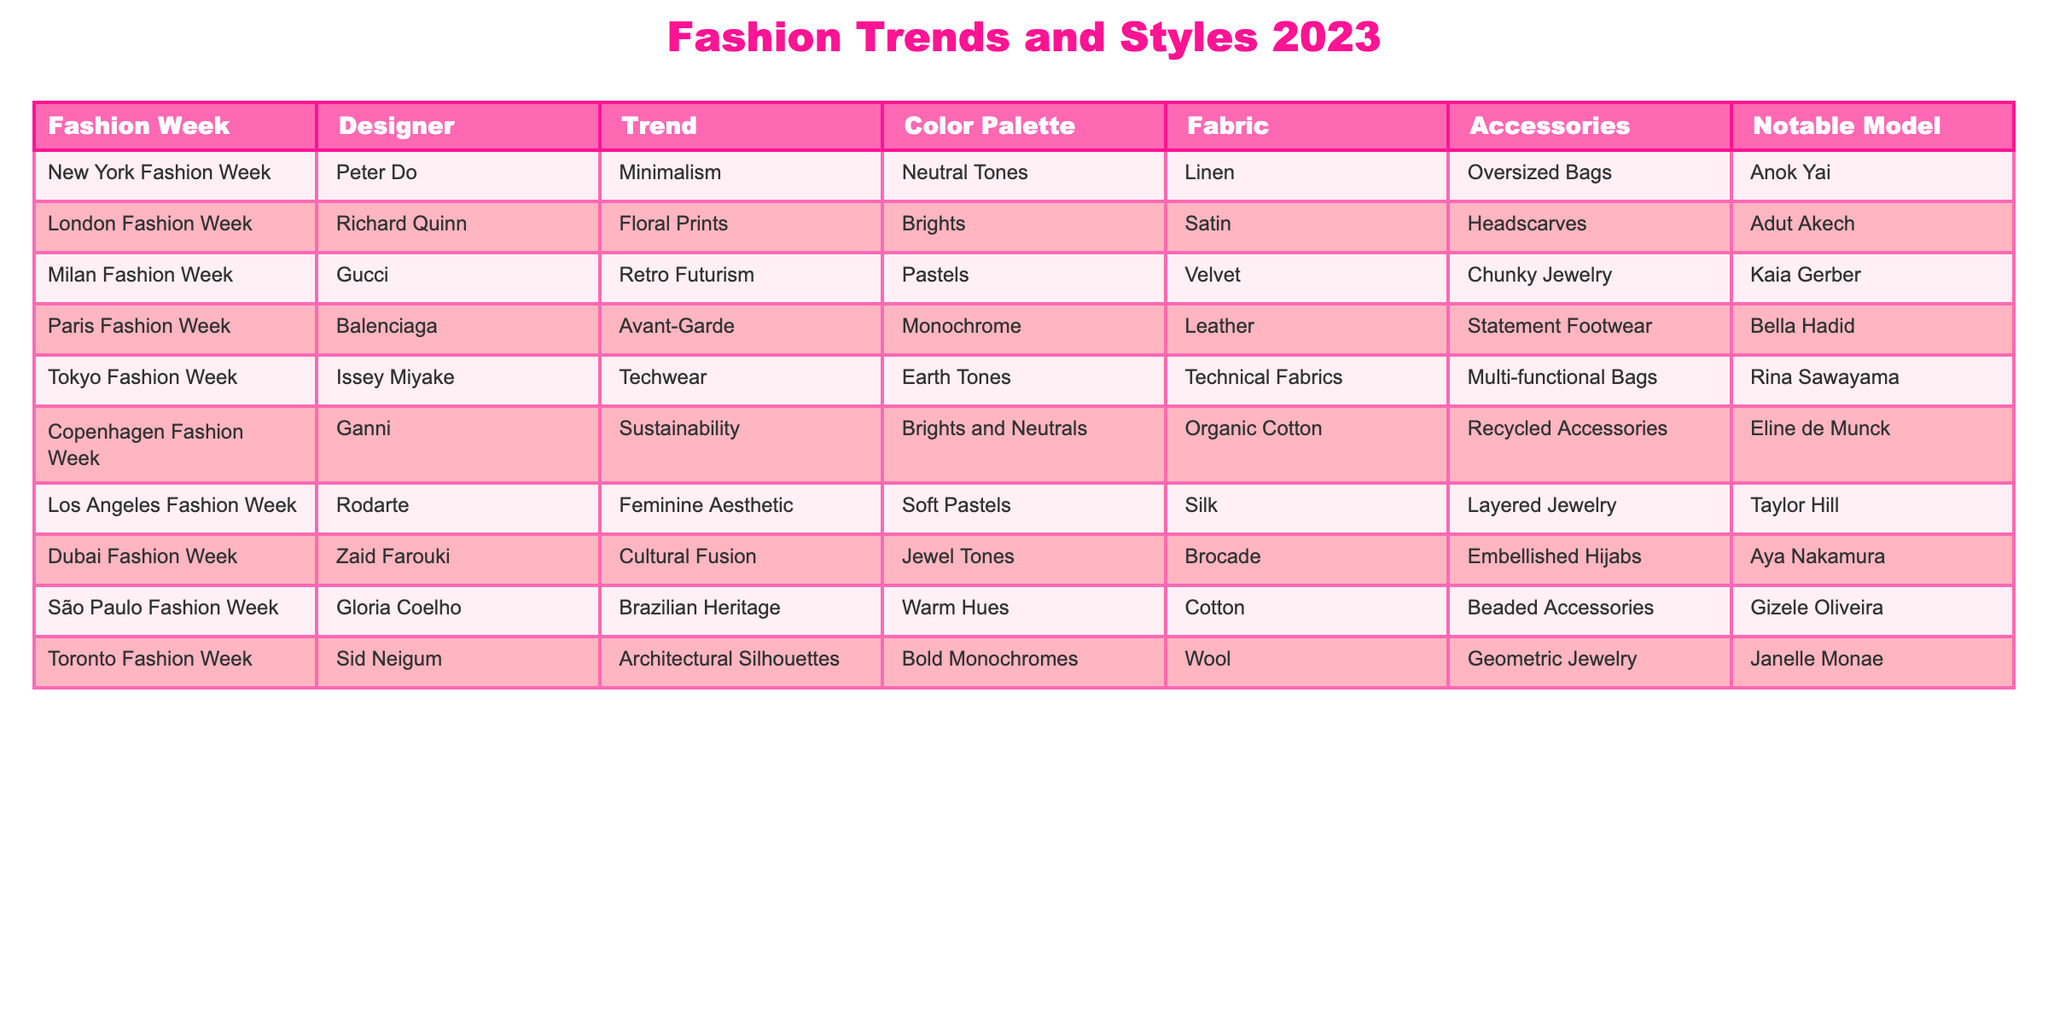What trend is associated with Issey Miyake? Issey Miyake is known for presenting the Techwear trend at Tokyo Fashion Week. This can be found directly in the table under the "Trend" column corresponding to Issey Miyake.
Answer: Techwear Which fashion week featured statement footwear as a notable accessory? The notable accessory "Statement Footwear" is linked to Balenciaga, which showcased at Paris Fashion Week according to the table.
Answer: Paris Fashion Week How many designers featured sustainability-related themes in their collections? By reviewing the table, Ganni's trend is explicitly labeled as "Sustainability." Since no other designers are listed with a similar focus, the count is 1.
Answer: 1 What color palette did Gucci utilize for their retro futurism trend? Gucci employed a "Pastels" color palette as outlined in the table, specifically tied to the Retro Futurism trend mentioned.
Answer: Pastels Are there any designers who used earth tones in their fabric palette? Yes, it is true that Issey Miyake utilized Earth Tones in the fabric palette for their collection. This fact can be verified through the table information.
Answer: Yes Which designer showcased floral prints and what was the associated color palette? Richard Quinn showcased floral prints at London Fashion Week, and his associated color palette was "Brights," as listed in the table.
Answer: Richard Quinn, Brights How does the average number of accessories vary among designers featuring feminine aesthetics? When examining the table, Rodarte featured "Layered Jewelry" as the singular accessory linked to the Feminine Aesthetic, resulting in 1 accessory for this trend. Since there is only one designer here, the average is simply that quantity.
Answer: 1 Which fashion week had a notable model named Anok Yai? Anok Yai is the notable model for Peter Do, who presented at New York Fashion Week as indicated in the data.
Answer: New York Fashion Week What is the trend of the designer associated with the color palette of jewel tones? Zaid Farouki represents a trend of Cultural Fusion, which corresponds with the jewel tones palette according to the table.
Answer: Cultural Fusion Which two fashion weeks featured bright colors and which designers were responsible for them? Both London Fashion Week and Copenhagen Fashion Week featured bright colors. Richard Quinn's collection included bright colors with floral prints, and Ganni's collection offered a mixture of bright and neutral colors labeled under sustainability.
Answer: London and Copenhagen Fashion Weeks, Richard Quinn and Ganni 